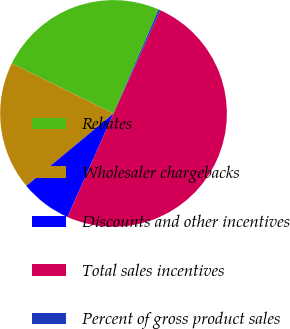Convert chart. <chart><loc_0><loc_0><loc_500><loc_500><pie_chart><fcel>Rebates<fcel>Wholesaler chargebacks<fcel>Discounts and other incentives<fcel>Total sales incentives<fcel>Percent of gross product sales<nl><fcel>24.23%<fcel>18.32%<fcel>7.31%<fcel>49.87%<fcel>0.27%<nl></chart> 